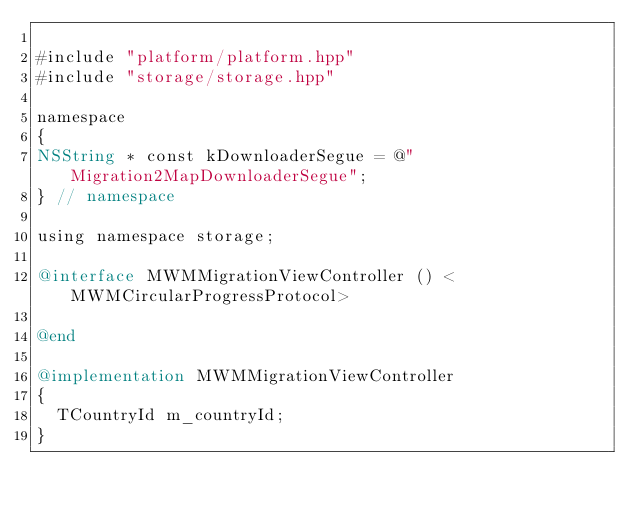Convert code to text. <code><loc_0><loc_0><loc_500><loc_500><_ObjectiveC_>
#include "platform/platform.hpp"
#include "storage/storage.hpp"

namespace
{
NSString * const kDownloaderSegue = @"Migration2MapDownloaderSegue";
} // namespace

using namespace storage;

@interface MWMMigrationViewController () <MWMCircularProgressProtocol>

@end

@implementation MWMMigrationViewController
{
  TCountryId m_countryId;
}
</code> 